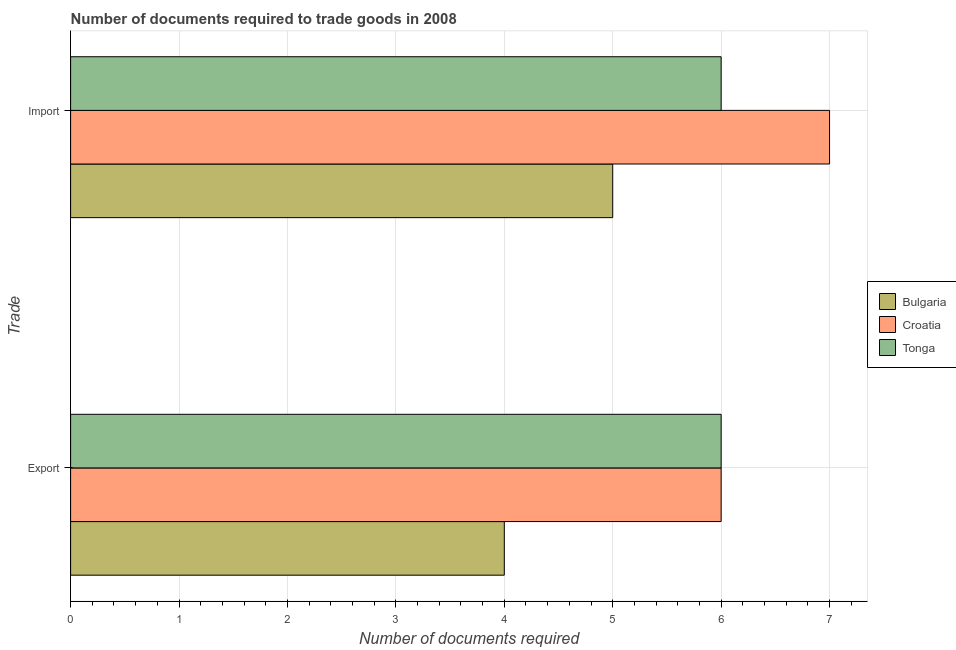How many different coloured bars are there?
Provide a short and direct response. 3. How many bars are there on the 1st tick from the top?
Your response must be concise. 3. How many bars are there on the 2nd tick from the bottom?
Offer a very short reply. 3. What is the label of the 1st group of bars from the top?
Keep it short and to the point. Import. Across all countries, what is the maximum number of documents required to import goods?
Make the answer very short. 7. Across all countries, what is the minimum number of documents required to import goods?
Offer a very short reply. 5. In which country was the number of documents required to export goods maximum?
Your answer should be very brief. Croatia. What is the total number of documents required to import goods in the graph?
Your answer should be very brief. 18. What is the difference between the number of documents required to export goods in Croatia and that in Bulgaria?
Give a very brief answer. 2. What is the difference between the number of documents required to export goods in Croatia and the number of documents required to import goods in Tonga?
Offer a terse response. 0. What is the average number of documents required to export goods per country?
Provide a short and direct response. 5.33. What is the difference between the number of documents required to export goods and number of documents required to import goods in Tonga?
Your response must be concise. 0. What does the 1st bar from the top in Export represents?
Your response must be concise. Tonga. What does the 3rd bar from the bottom in Import represents?
Ensure brevity in your answer.  Tonga. How many bars are there?
Your response must be concise. 6. Are all the bars in the graph horizontal?
Your answer should be compact. Yes. What is the title of the graph?
Ensure brevity in your answer.  Number of documents required to trade goods in 2008. What is the label or title of the X-axis?
Give a very brief answer. Number of documents required. What is the label or title of the Y-axis?
Keep it short and to the point. Trade. What is the Number of documents required of Bulgaria in Export?
Offer a very short reply. 4. What is the Number of documents required of Croatia in Export?
Keep it short and to the point. 6. What is the Number of documents required of Tonga in Export?
Offer a terse response. 6. What is the Number of documents required of Bulgaria in Import?
Offer a terse response. 5. What is the Number of documents required of Croatia in Import?
Provide a succinct answer. 7. What is the Number of documents required in Tonga in Import?
Your answer should be compact. 6. Across all Trade, what is the minimum Number of documents required of Bulgaria?
Your answer should be very brief. 4. Across all Trade, what is the minimum Number of documents required of Tonga?
Keep it short and to the point. 6. What is the difference between the Number of documents required in Croatia in Export and that in Import?
Keep it short and to the point. -1. What is the difference between the Number of documents required of Bulgaria in Export and the Number of documents required of Tonga in Import?
Keep it short and to the point. -2. What is the difference between the Number of documents required in Croatia in Export and the Number of documents required in Tonga in Import?
Ensure brevity in your answer.  0. What is the average Number of documents required of Croatia per Trade?
Keep it short and to the point. 6.5. What is the average Number of documents required in Tonga per Trade?
Your answer should be very brief. 6. What is the difference between the Number of documents required in Bulgaria and Number of documents required in Croatia in Import?
Ensure brevity in your answer.  -2. What is the ratio of the Number of documents required in Bulgaria in Export to that in Import?
Keep it short and to the point. 0.8. What is the ratio of the Number of documents required of Croatia in Export to that in Import?
Make the answer very short. 0.86. What is the difference between the highest and the second highest Number of documents required of Croatia?
Your response must be concise. 1. What is the difference between the highest and the lowest Number of documents required in Bulgaria?
Provide a short and direct response. 1. What is the difference between the highest and the lowest Number of documents required of Croatia?
Your answer should be compact. 1. What is the difference between the highest and the lowest Number of documents required of Tonga?
Keep it short and to the point. 0. 